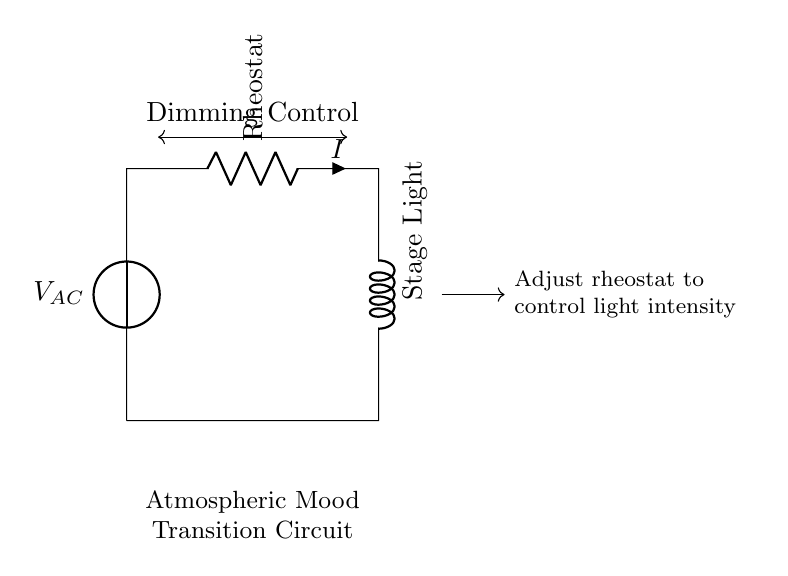What component controls the light intensity? The rheostat is used to adjust the resistance in the circuit, thus controlling the current passing through the stage light and, consequently, the light intensity.
Answer: Rheostat What is the function of the inductor in this circuit? The inductor, often represented by the stage light in this circuit, stores energy in a magnetic field when current passes through it. This helps in providing a smooth transition in light intensity during dimming, preventing sudden changes that could disturb the atmosphere.
Answer: Stage Light What type of voltage source is used? The voltage source shown is an alternating current (AC) supply, as indicated by the notation on the diagram. It typically provides a sinusoidal voltage that varies over time, which is suitable for stage lighting applications.
Answer: AC How does adjusting the rheostat affect the current? Increasing the resistance of the rheostat reduces the overall current in the circuit based on Ohm's Law, where resistance is inversely proportional to current for a constant voltage. Hence, adjusting it downwards allows more current to flow, leading to brighter lighting.
Answer: Decreases current What type of circuit configuration is this? The circuit displays a series configuration as all components are connected end-to-end, forming a single path for current to flow from the power source through the rheostat and inductor (stage light).
Answer: Series What will happen if the resistance is set to zero? Setting the resistance of the rheostat to zero would result in the maximum current flowing through the stage light, potentially causing it to burn out due to excess power, depending on the light’s specifications.
Answer: Maximum current 